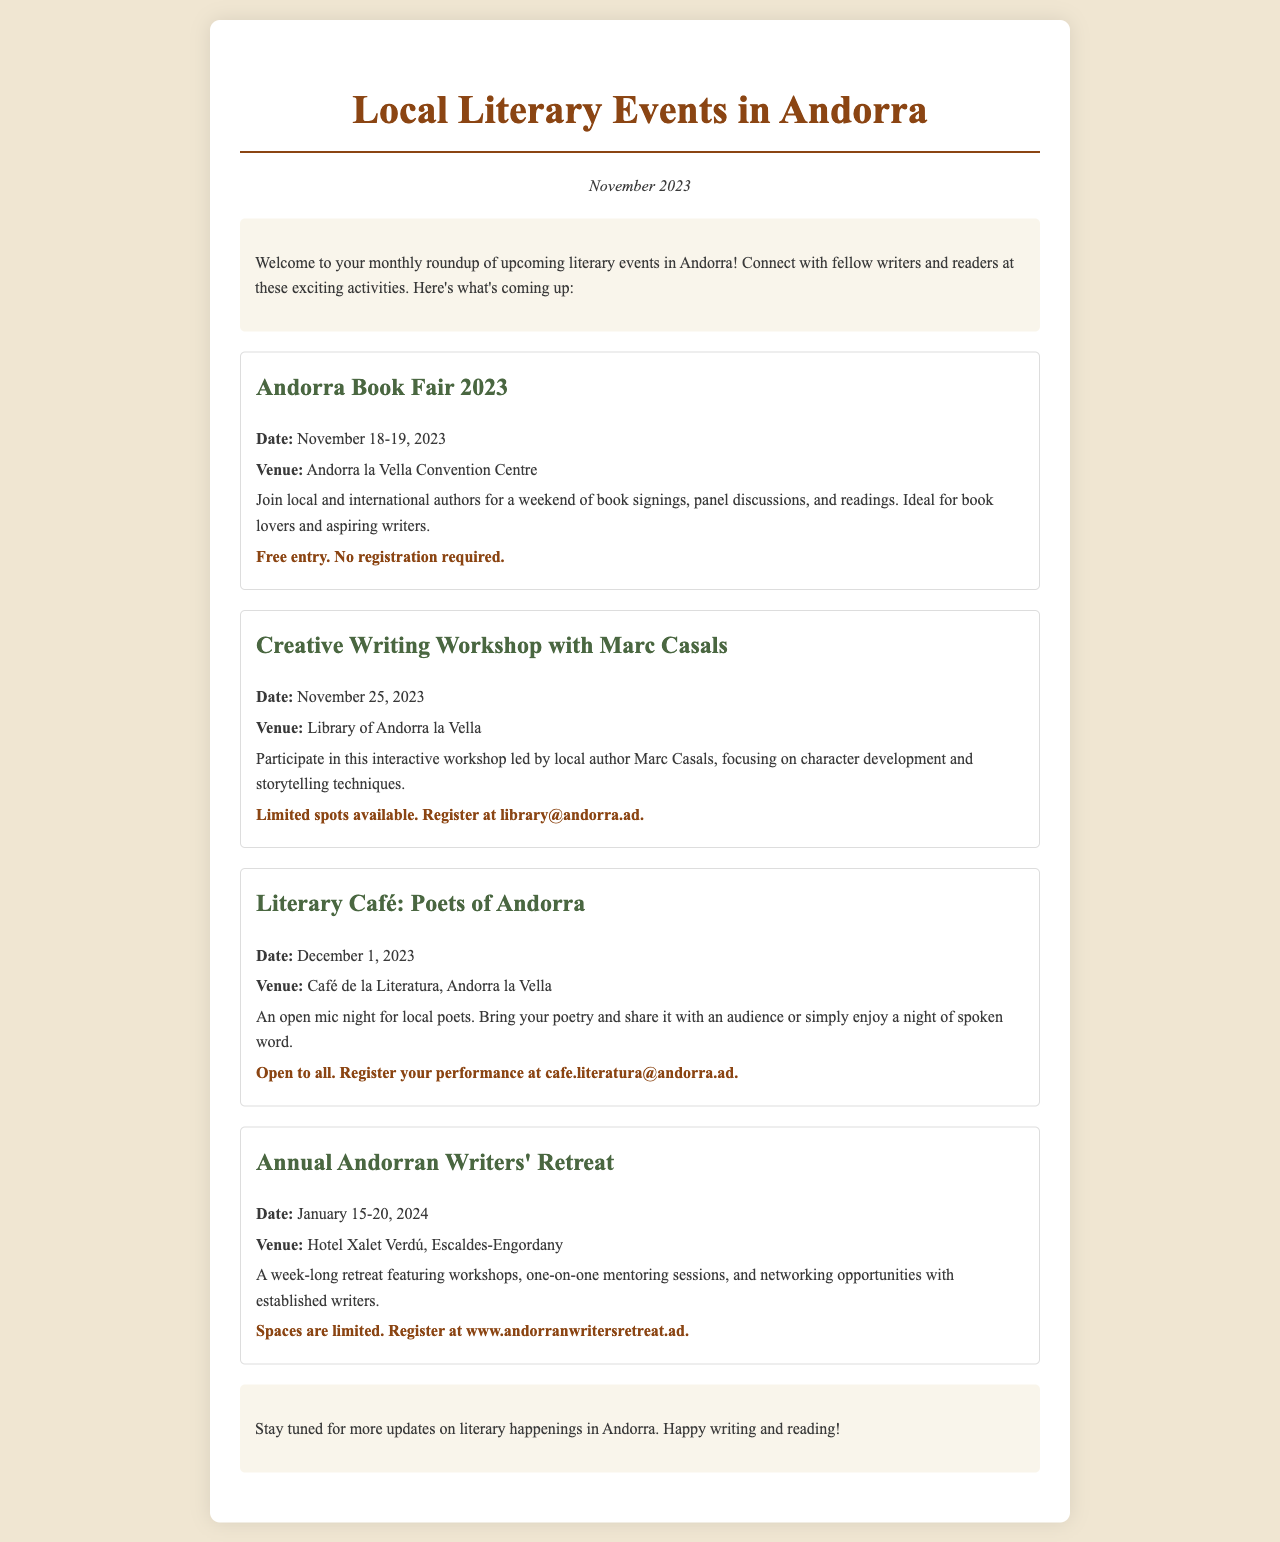What is the date of the Andorra Book Fair 2023? The document states that the event is taking place on November 18-19, 2023.
Answer: November 18-19, 2023 Where will the Creative Writing Workshop take place? The venue for the Creative Writing Workshop is mentioned as the Library of Andorra la Vella.
Answer: Library of Andorra la Vella Who is leading the Creative Writing Workshop? The document identifies Marc Casals as the leader of the workshop.
Answer: Marc Casals How many events are listed in the newsletter? There are a total of four distinct literary events mentioned in the document.
Answer: Four What type of event is scheduled for December 1, 2023? The event on December 1 is described as an open mic night for local poets.
Answer: Open mic night What is required to participate in the Annual Andorran Writers' Retreat? To participate, individuals must register, as spaces are limited.
Answer: Register Is there a registration fee for the Andorra Book Fair? The document specifies that there is no registration fee for attending the Andorra Book Fair.
Answer: Free entry What is the primary focus of the Creative Writing Workshop? The workshop focuses on character development and storytelling techniques.
Answer: Character development and storytelling techniques What should you do to register for the Literary Café? Registration for the Literary Café performance can be done via email at cafe.literatura@andorra.ad.
Answer: Email registration 